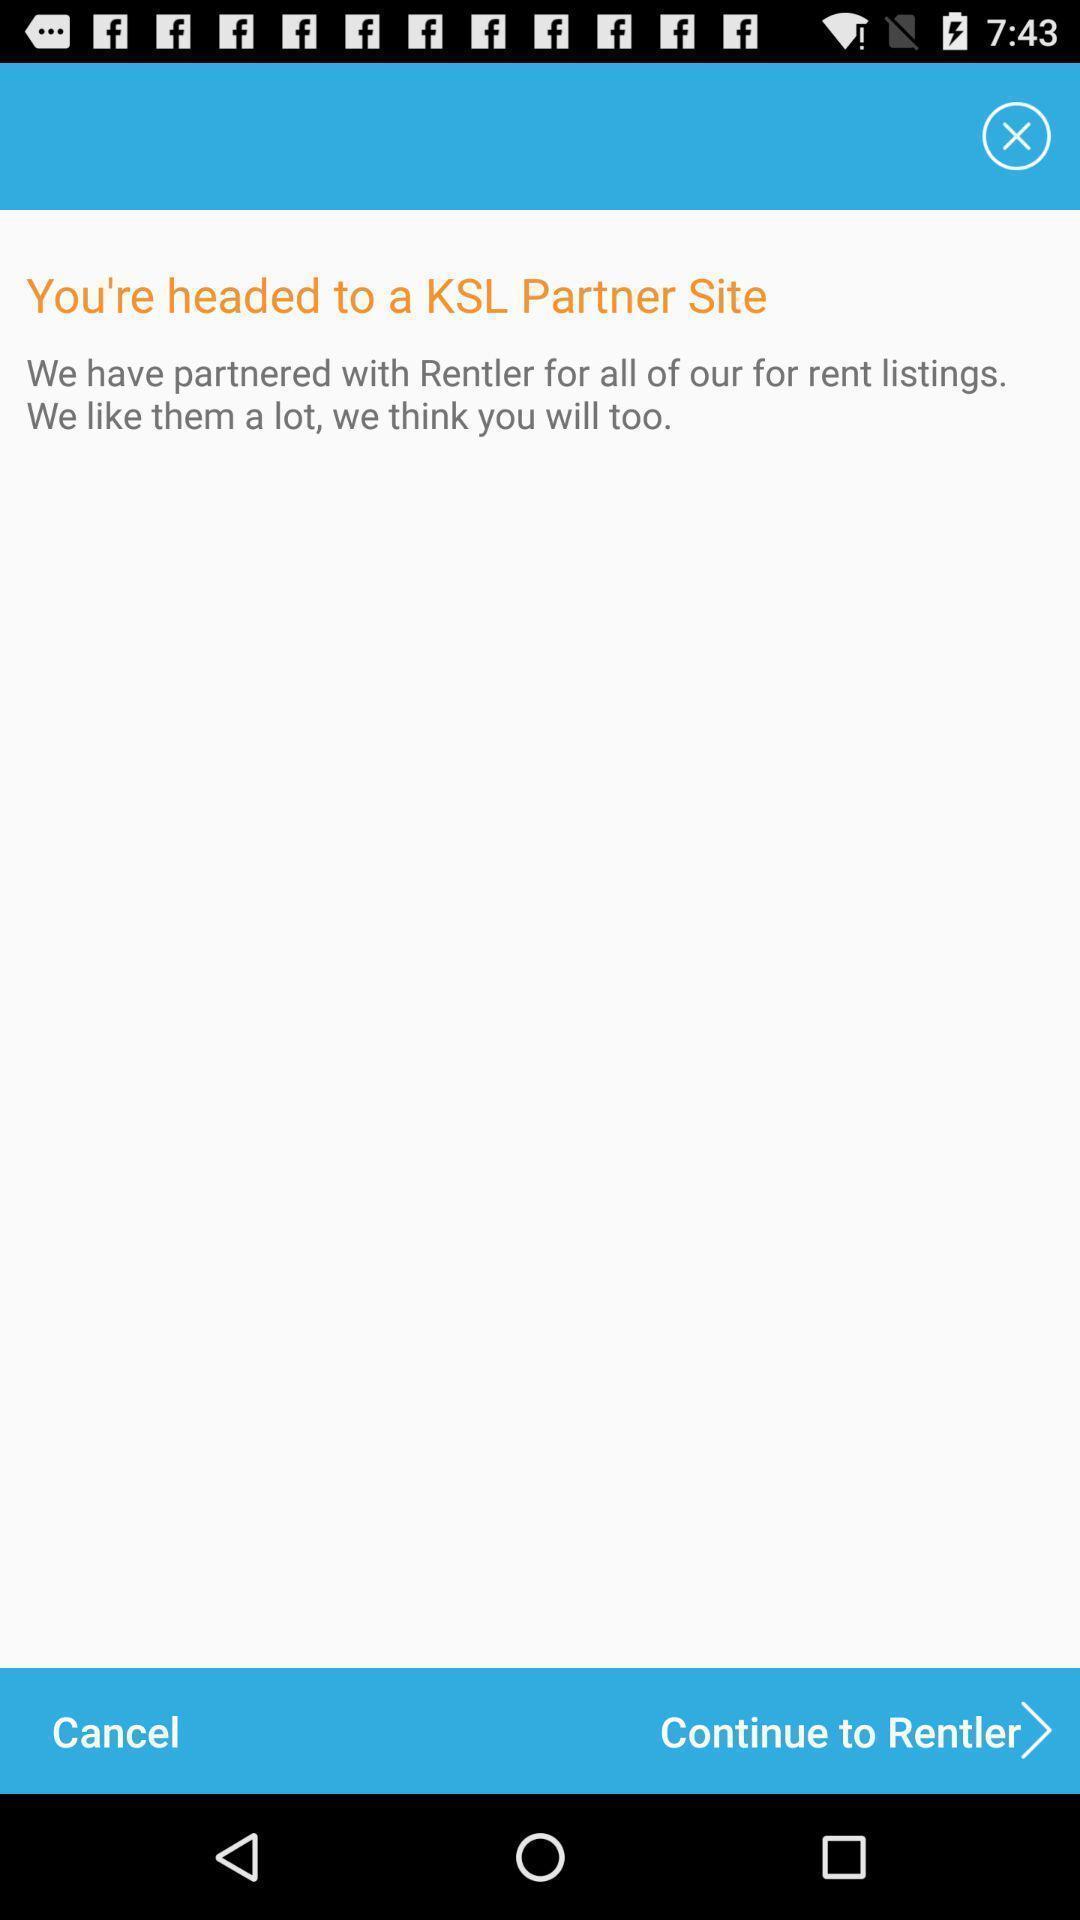Tell me about the visual elements in this screen capture. Screen displaying the page of the rent app. 